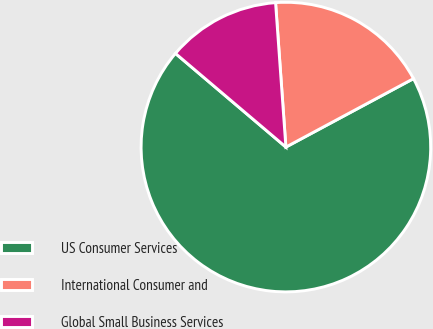Convert chart to OTSL. <chart><loc_0><loc_0><loc_500><loc_500><pie_chart><fcel>US Consumer Services<fcel>International Consumer and<fcel>Global Small Business Services<nl><fcel>69.03%<fcel>18.3%<fcel>12.67%<nl></chart> 